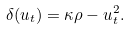Convert formula to latex. <formula><loc_0><loc_0><loc_500><loc_500>\delta ( u _ { t } ) = \kappa \rho - u _ { t } ^ { 2 } .</formula> 